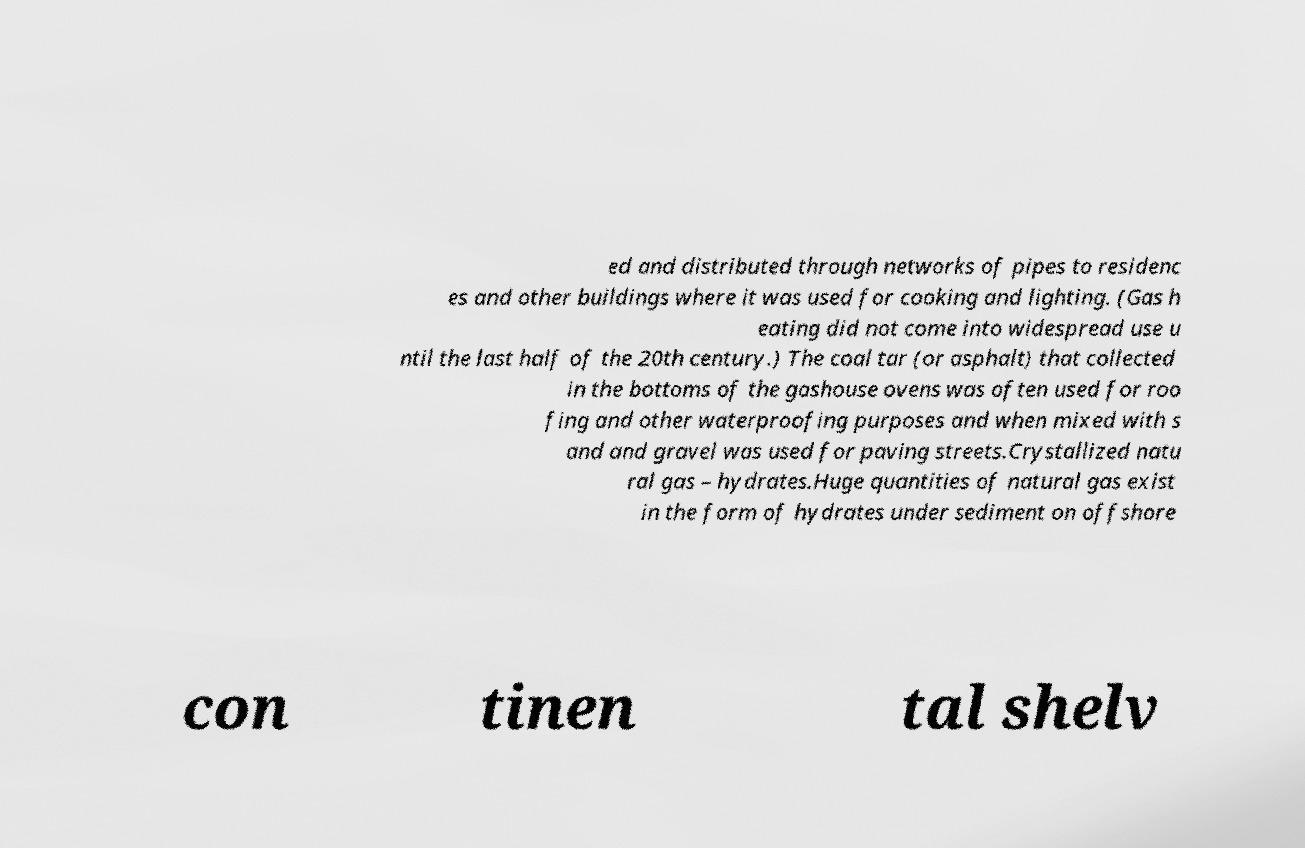Please read and relay the text visible in this image. What does it say? ed and distributed through networks of pipes to residenc es and other buildings where it was used for cooking and lighting. (Gas h eating did not come into widespread use u ntil the last half of the 20th century.) The coal tar (or asphalt) that collected in the bottoms of the gashouse ovens was often used for roo fing and other waterproofing purposes and when mixed with s and and gravel was used for paving streets.Crystallized natu ral gas – hydrates.Huge quantities of natural gas exist in the form of hydrates under sediment on offshore con tinen tal shelv 